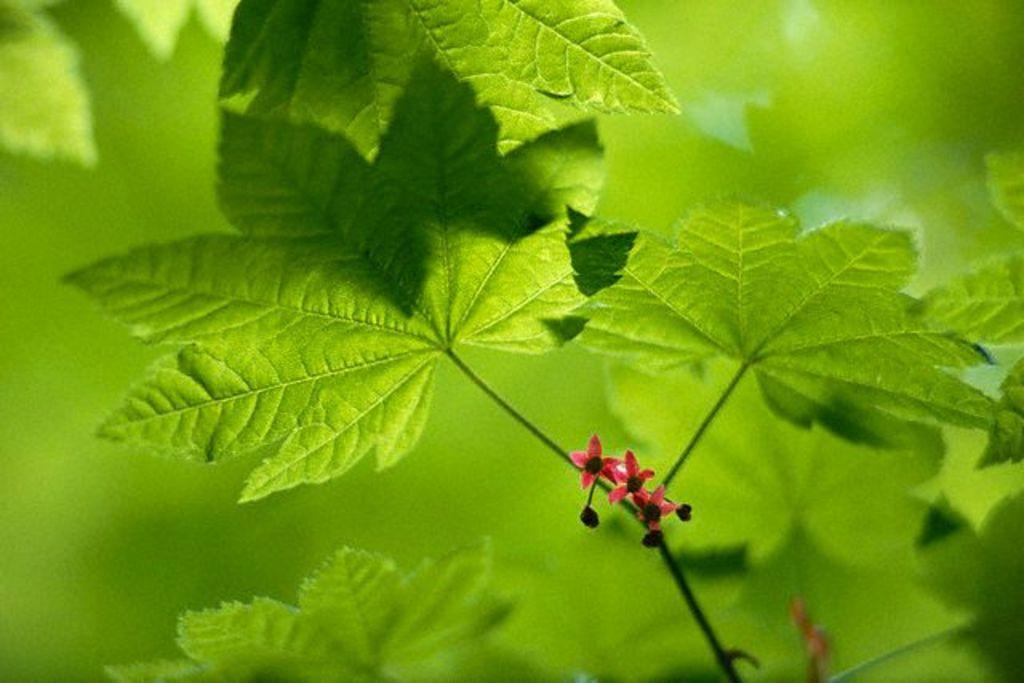Can you describe this image briefly? Here we can see a plant with small flowers. In the background the image is blur. 